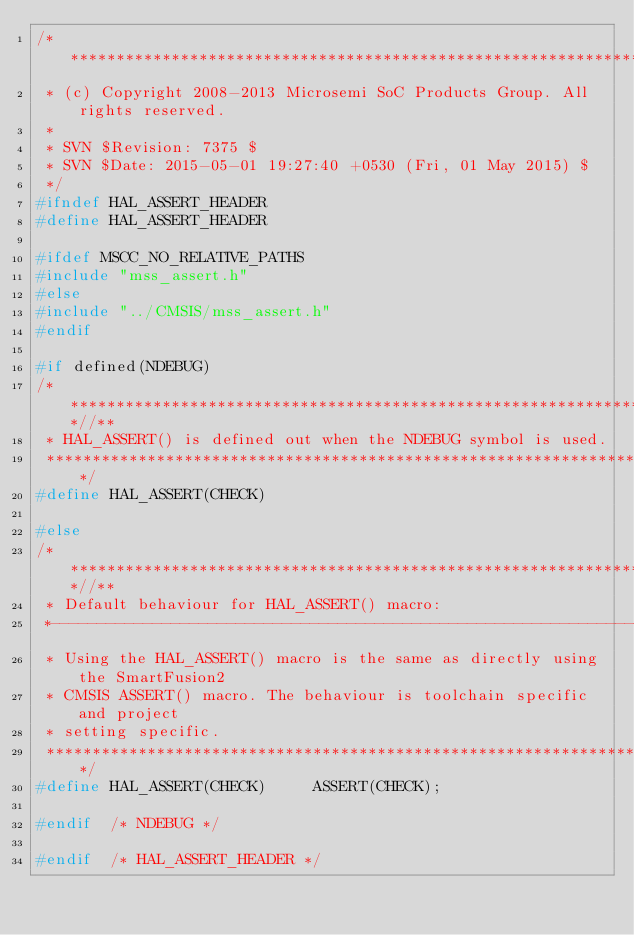<code> <loc_0><loc_0><loc_500><loc_500><_C_>/*******************************************************************************
 * (c) Copyright 2008-2013 Microsemi SoC Products Group. All rights reserved.
 * 
 * SVN $Revision: 7375 $
 * SVN $Date: 2015-05-01 19:27:40 +0530 (Fri, 01 May 2015) $
 */
#ifndef HAL_ASSERT_HEADER
#define HAL_ASSERT_HEADER

#ifdef MSCC_NO_RELATIVE_PATHS
#include "mss_assert.h"
#else
#include "../CMSIS/mss_assert.h"
#endif

#if defined(NDEBUG)
/***************************************************************************//**
 * HAL_ASSERT() is defined out when the NDEBUG symbol is used.
 ******************************************************************************/
#define HAL_ASSERT(CHECK)

#else
/***************************************************************************//**
 * Default behaviour for HAL_ASSERT() macro:
 *------------------------------------------------------------------------------
 * Using the HAL_ASSERT() macro is the same as directly using the SmartFusion2
 * CMSIS ASSERT() macro. The behaviour is toolchain specific and project
 * setting specific.
 ******************************************************************************/
#define HAL_ASSERT(CHECK)     ASSERT(CHECK);

#endif  /* NDEBUG */

#endif  /* HAL_ASSERT_HEADER */
</code> 